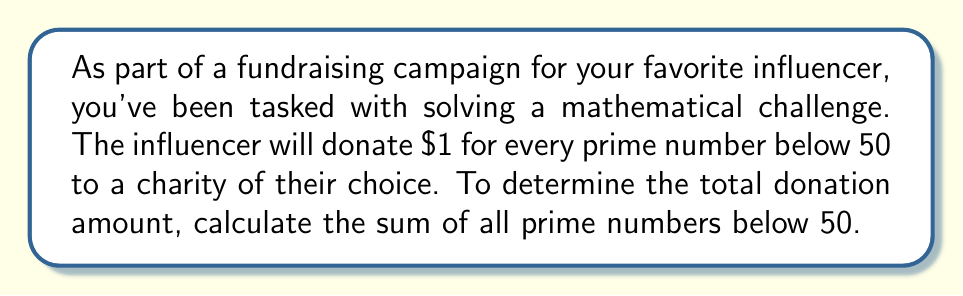Teach me how to tackle this problem. To solve this problem, we need to follow these steps:

1. Identify all prime numbers below 50
2. Sum these prime numbers

Let's begin:

1. Identifying prime numbers below 50:
   - 2 is the smallest prime number
   - 3 is prime
   - 5 is prime
   - 7 is prime
   - 11 is prime
   - 13 is prime
   - 17 is prime
   - 19 is prime
   - 23 is prime
   - 29 is prime
   - 31 is prime
   - 37 is prime
   - 41 is prime
   - 43 is prime
   - 47 is prime

2. Summing these prime numbers:

   $$\begin{align}
   S &= 2 + 3 + 5 + 7 + 11 + 13 + 17 + 19 + 23 + 29 + 31 + 37 + 41 + 43 + 47 \\
   &= (2 + 3 + 5 + 7) + (11 + 13 + 17 + 19) + (23 + 29 + 31) + (37 + 41 + 43 + 47) \\
   &= 17 + 60 + 83 + 168 \\
   &= 328
   \end{align}$$

Therefore, the sum of all prime numbers below 50 is 328.
Answer: $328 